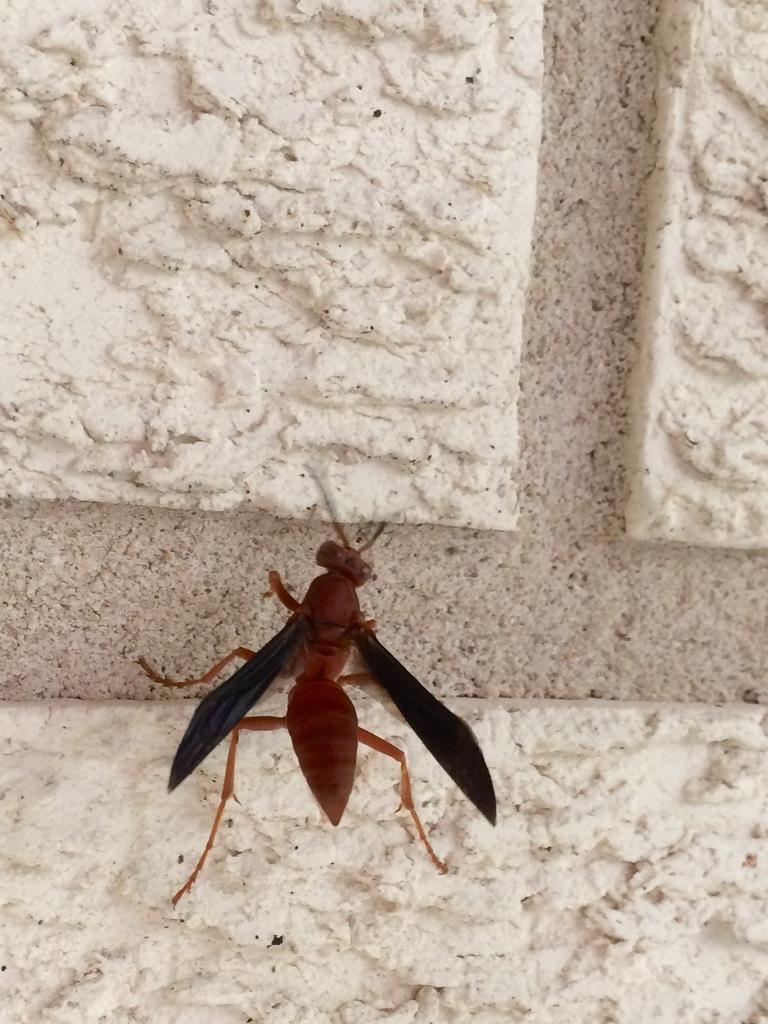What is the main subject of the image? There is an insect in the center of the image. What can be seen in the background of the image? There is a wall in the background of the image. What is the best way to spring the insect off the wall in the image? There is no need to spring the insect off the wall, as it is not necessary or advisable to interact with the insect in the image. 